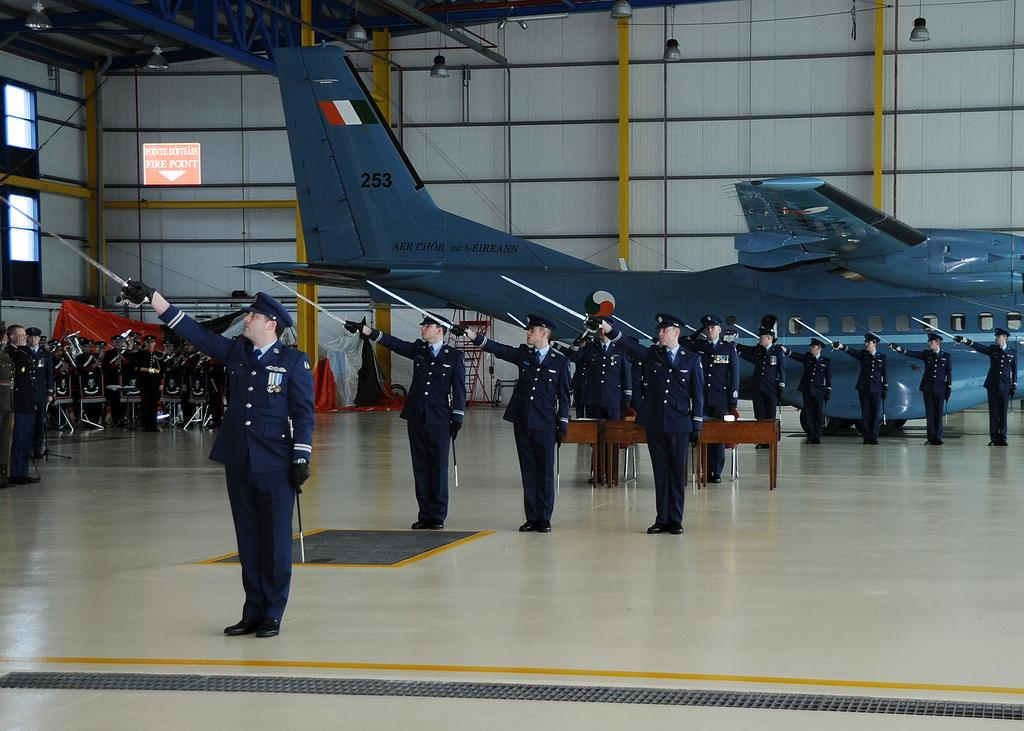<image>
Offer a succinct explanation of the picture presented. A few people stand in position i front of a plane with 253 on the tail. 